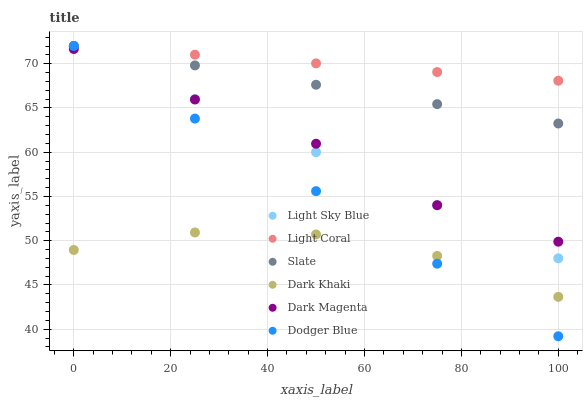Does Dark Khaki have the minimum area under the curve?
Answer yes or no. Yes. Does Light Coral have the maximum area under the curve?
Answer yes or no. Yes. Does Dark Magenta have the minimum area under the curve?
Answer yes or no. No. Does Dark Magenta have the maximum area under the curve?
Answer yes or no. No. Is Dodger Blue the smoothest?
Answer yes or no. Yes. Is Dark Khaki the roughest?
Answer yes or no. Yes. Is Dark Magenta the smoothest?
Answer yes or no. No. Is Dark Magenta the roughest?
Answer yes or no. No. Does Dodger Blue have the lowest value?
Answer yes or no. Yes. Does Dark Magenta have the lowest value?
Answer yes or no. No. Does Dodger Blue have the highest value?
Answer yes or no. Yes. Does Dark Magenta have the highest value?
Answer yes or no. No. Is Dark Magenta less than Light Coral?
Answer yes or no. Yes. Is Light Coral greater than Dark Khaki?
Answer yes or no. Yes. Does Dodger Blue intersect Light Coral?
Answer yes or no. Yes. Is Dodger Blue less than Light Coral?
Answer yes or no. No. Is Dodger Blue greater than Light Coral?
Answer yes or no. No. Does Dark Magenta intersect Light Coral?
Answer yes or no. No. 